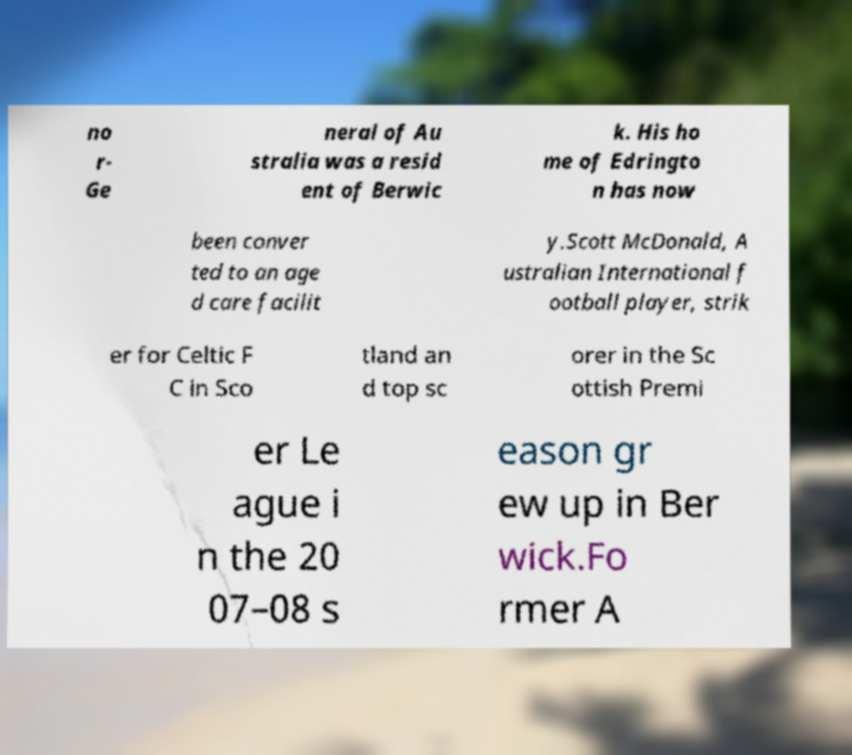Can you accurately transcribe the text from the provided image for me? no r- Ge neral of Au stralia was a resid ent of Berwic k. His ho me of Edringto n has now been conver ted to an age d care facilit y.Scott McDonald, A ustralian International f ootball player, strik er for Celtic F C in Sco tland an d top sc orer in the Sc ottish Premi er Le ague i n the 20 07–08 s eason gr ew up in Ber wick.Fo rmer A 